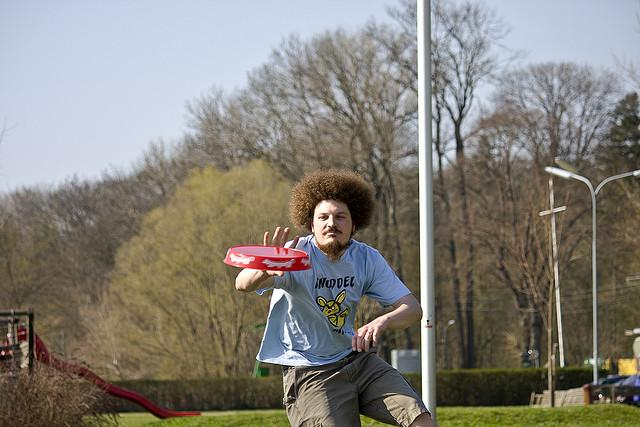What can be played on here? Please explain your reasoning. slide. There is a red slide in the background. 